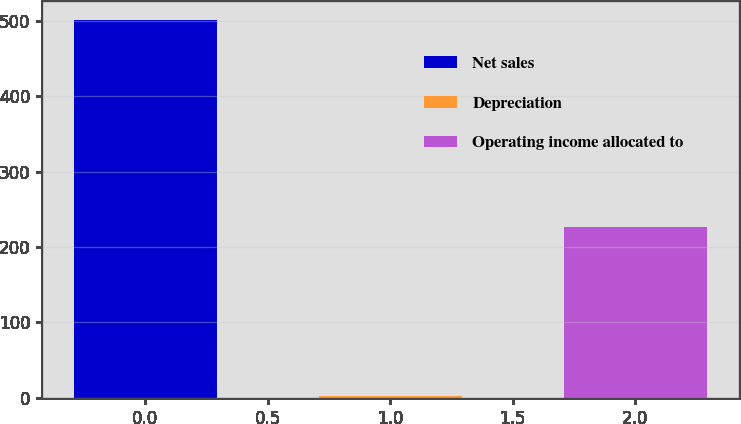Convert chart to OTSL. <chart><loc_0><loc_0><loc_500><loc_500><bar_chart><fcel>Net sales<fcel>Depreciation<fcel>Operating income allocated to<nl><fcel>501<fcel>2<fcel>227<nl></chart> 